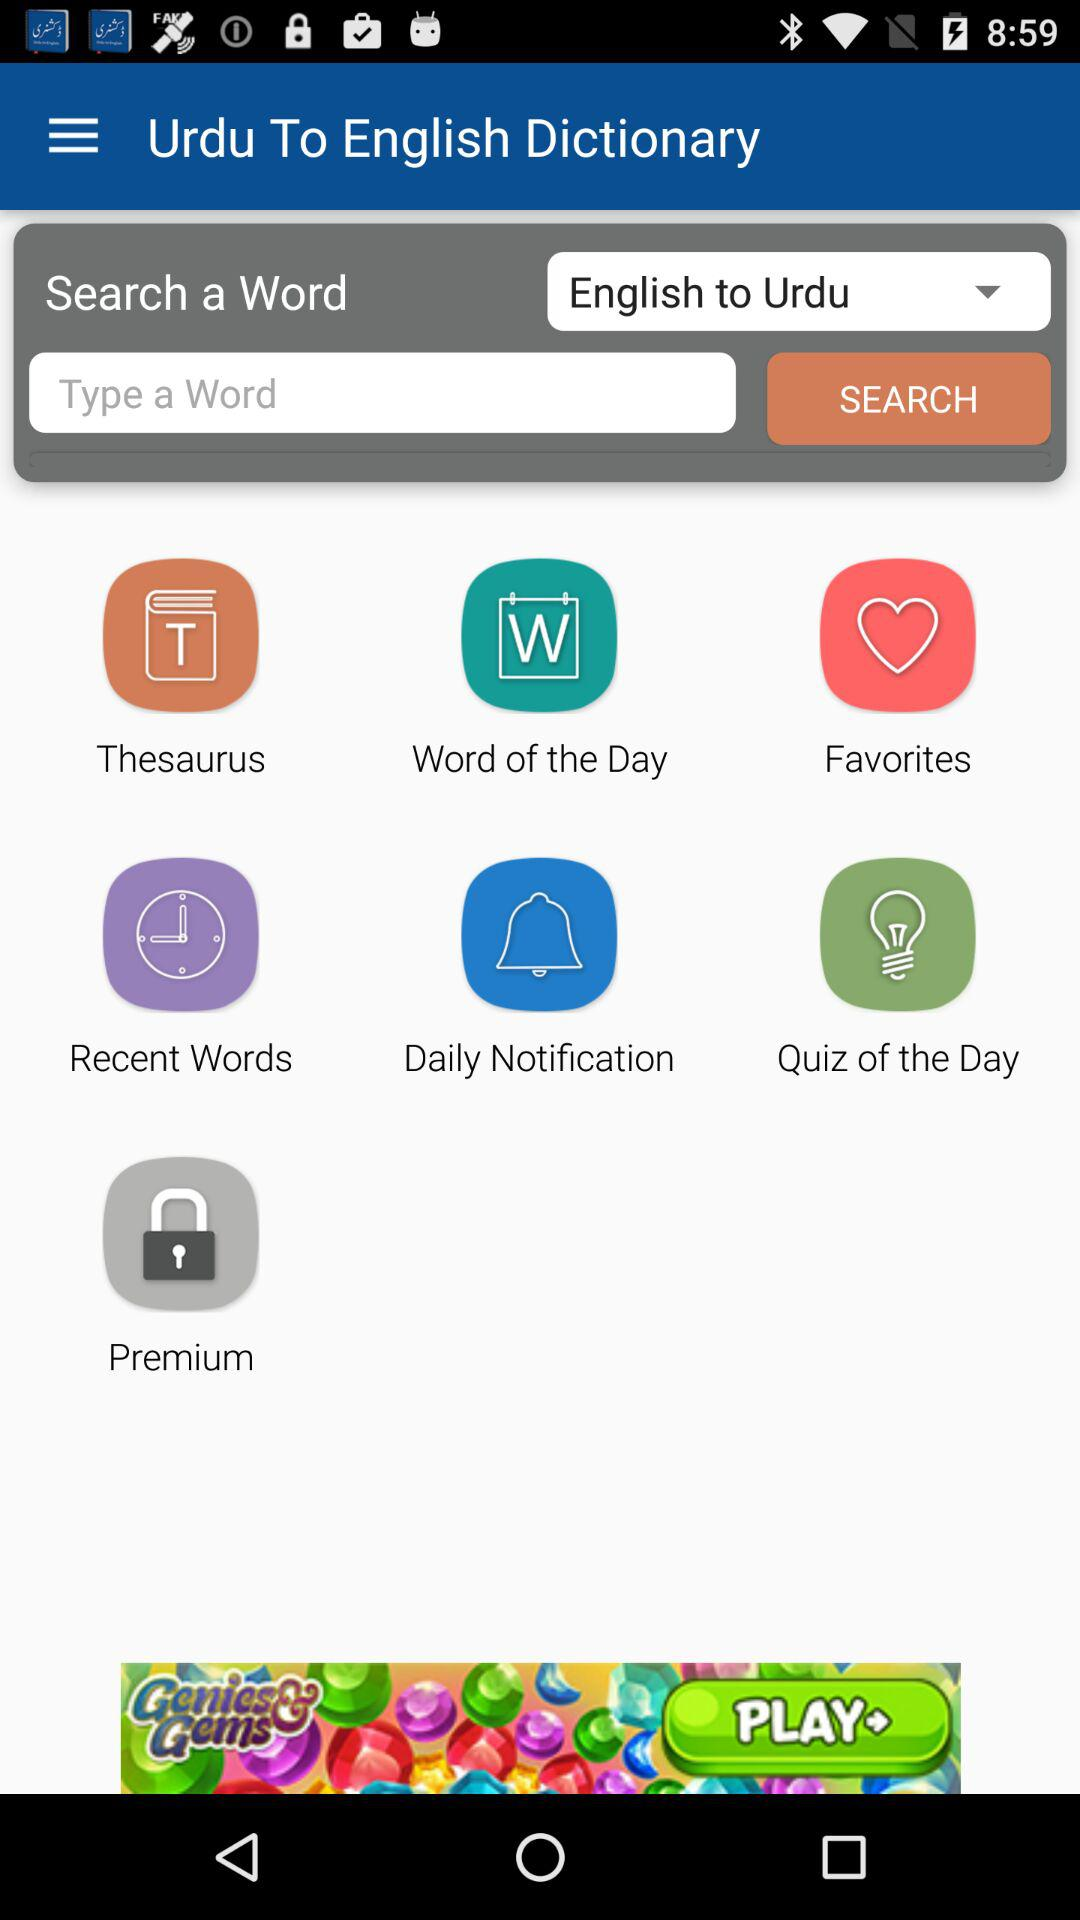What is the language selected?
When the provided information is insufficient, respond with <no answer>. <no answer> 